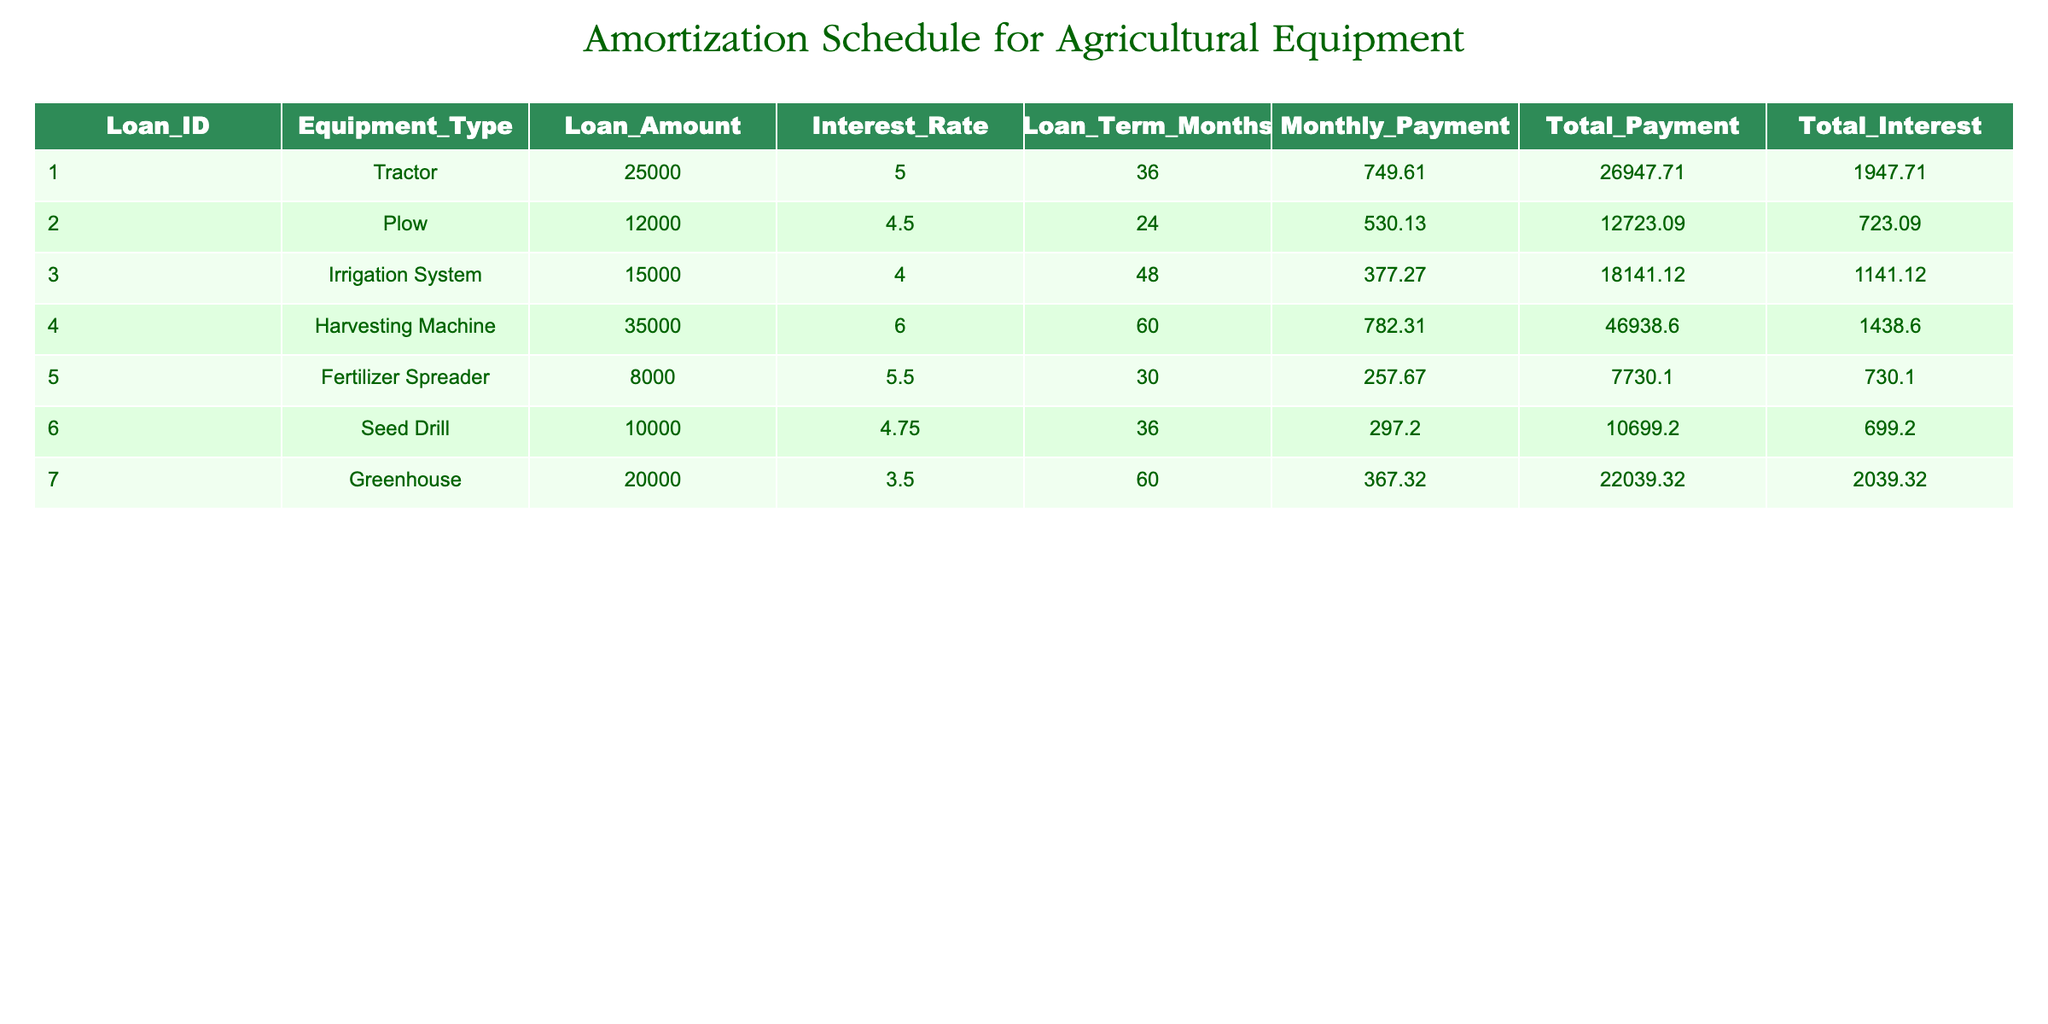What is the loan amount for the 'Greenhouse'? By looking at the row corresponding to 'Greenhouse', I can see that the loan amount specified is 20000.
Answer: 20000 What is the total payment for the 'Plow'? In the row for 'Plow', the total payment is explicitly listed as 12723.09.
Answer: 12723.09 What is the interest rate for the 'Harvesting Machine'? The interest rate column for the 'Harvesting Machine' shows a rate of 6.0.
Answer: 6.0 What is the average loan amount for agricultural equipment in this table? To find the average loan amount, I sum all loan amounts (25000 + 12000 + 15000 + 35000 + 8000 + 10000 + 20000 = 125000) and divide by the number of entries (7). So, it’s 125000 / 7 = 17857.14.
Answer: 17857.14 Is the monthly payment for the 'Fertilizer Spreader' less than 300? The monthly payment for the 'Fertilizer Spreader' is 257.67, which is indeed less than 300.
Answer: Yes What is the total interest paid for the equipment with the highest interest rate? The highest interest rate is 6.0 for the 'Harvesting Machine', which has a total interest of 1438.60.
Answer: 1438.60 Which equipment type has the highest total payment, and what is that payment? The 'Harvesting Machine' has the highest total payment of 46938.60, as I can see when comparing the total payment column across all types.
Answer: Harvesting Machine, 46938.60 What is the difference in monthly payment between the 'Irrigation System' and 'Seed Drill'? The monthly payment for the 'Irrigation System' is 377.27, and for the 'Seed Drill', it is 297.20. The difference is 377.27 - 297.20 = 80.07.
Answer: 80.07 Is the total payment for the 'Tractor' greater than the total payment for the 'Seed Drill'? The total payment for the 'Tractor' is 26947.71, while for the 'Seed Drill' it is 10699.20. Since 26947.71 is greater than 10699.20, the statement is true.
Answer: Yes 